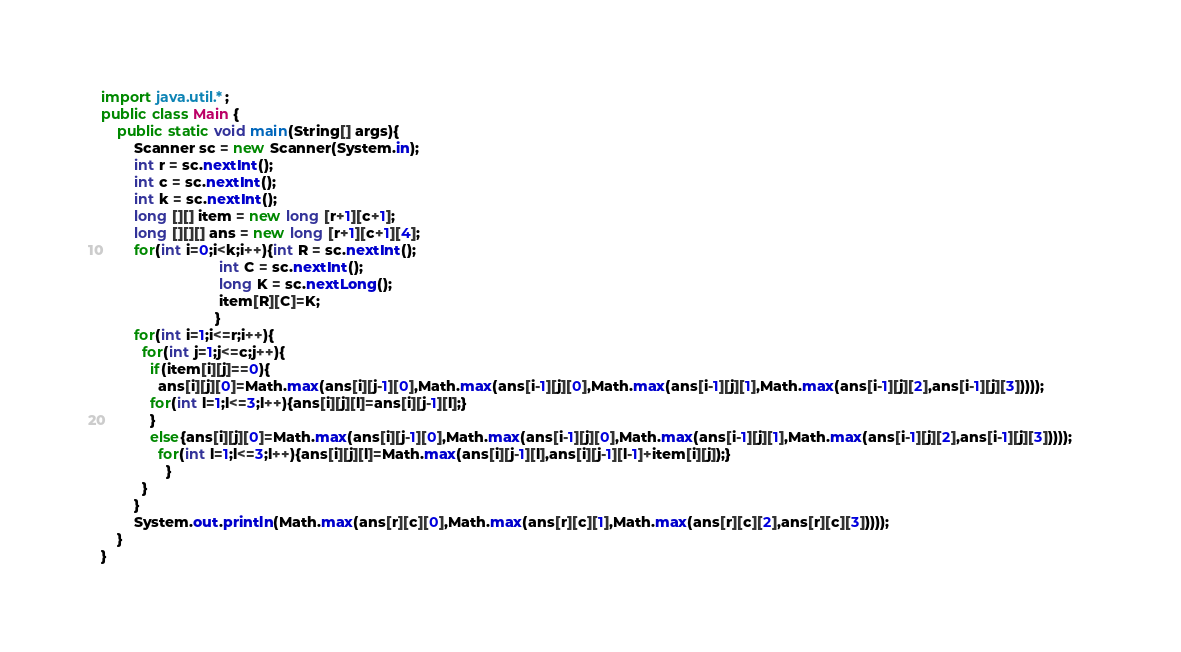Convert code to text. <code><loc_0><loc_0><loc_500><loc_500><_Java_>import java.util.*;
public class Main {
	public static void main(String[] args){
		Scanner sc = new Scanner(System.in);
		int r = sc.nextInt();
        int c = sc.nextInt();
        int k = sc.nextInt();
		long [][] item = new long [r+1][c+1];
        long [][][] ans = new long [r+1][c+1][4];
        for(int i=0;i<k;i++){int R = sc.nextInt();
                             int C = sc.nextInt();
                             long K = sc.nextLong();
                             item[R][C]=K;
                            }		
        for(int i=1;i<=r;i++){                              
          for(int j=1;j<=c;j++){                               
            if(item[i][j]==0){                                
              ans[i][j][0]=Math.max(ans[i][j-1][0],Math.max(ans[i-1][j][0],Math.max(ans[i-1][j][1],Math.max(ans[i-1][j][2],ans[i-1][j][3]))));            
            for(int l=1;l<=3;l++){ans[i][j][l]=ans[i][j-1][l];}
            }
            else{ans[i][j][0]=Math.max(ans[i][j-1][0],Math.max(ans[i-1][j][0],Math.max(ans[i-1][j][1],Math.max(ans[i-1][j][2],ans[i-1][j][3]))));
              for(int l=1;l<=3;l++){ans[i][j][l]=Math.max(ans[i][j-1][l],ans[i][j-1][l-1]+item[i][j]);}           
                }                                  
          } 
        }      
		System.out.println(Math.max(ans[r][c][0],Math.max(ans[r][c][1],Math.max(ans[r][c][2],ans[r][c][3]))));
	}
}</code> 